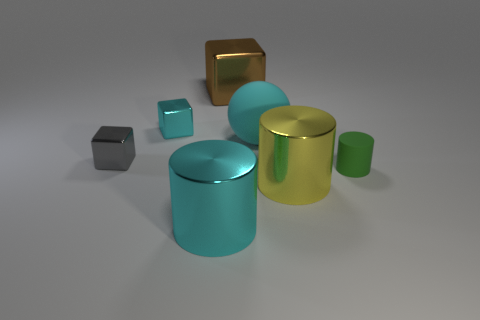There is a small metallic object that is the same color as the large sphere; what shape is it?
Offer a terse response. Cube. Are there any cyan things made of the same material as the tiny cyan block?
Your answer should be compact. Yes. Is there anything else that has the same material as the cyan sphere?
Keep it short and to the point. Yes. What is the cube that is to the right of the cyan metallic thing that is in front of the large yellow shiny cylinder made of?
Your response must be concise. Metal. There is a metal cylinder right of the matte thing to the left of the thing right of the yellow cylinder; what size is it?
Your answer should be compact. Large. What number of other objects are there of the same shape as the big brown metallic object?
Your response must be concise. 2. There is a big cylinder that is right of the brown metal block; is it the same color as the matte object that is to the left of the tiny green rubber thing?
Keep it short and to the point. No. There is a rubber sphere that is the same size as the brown metallic block; what color is it?
Make the answer very short. Cyan. Is there a small block of the same color as the big metallic cube?
Offer a very short reply. No. There is a cyan metal object that is in front of the green rubber thing; is its size the same as the big ball?
Ensure brevity in your answer.  Yes. 